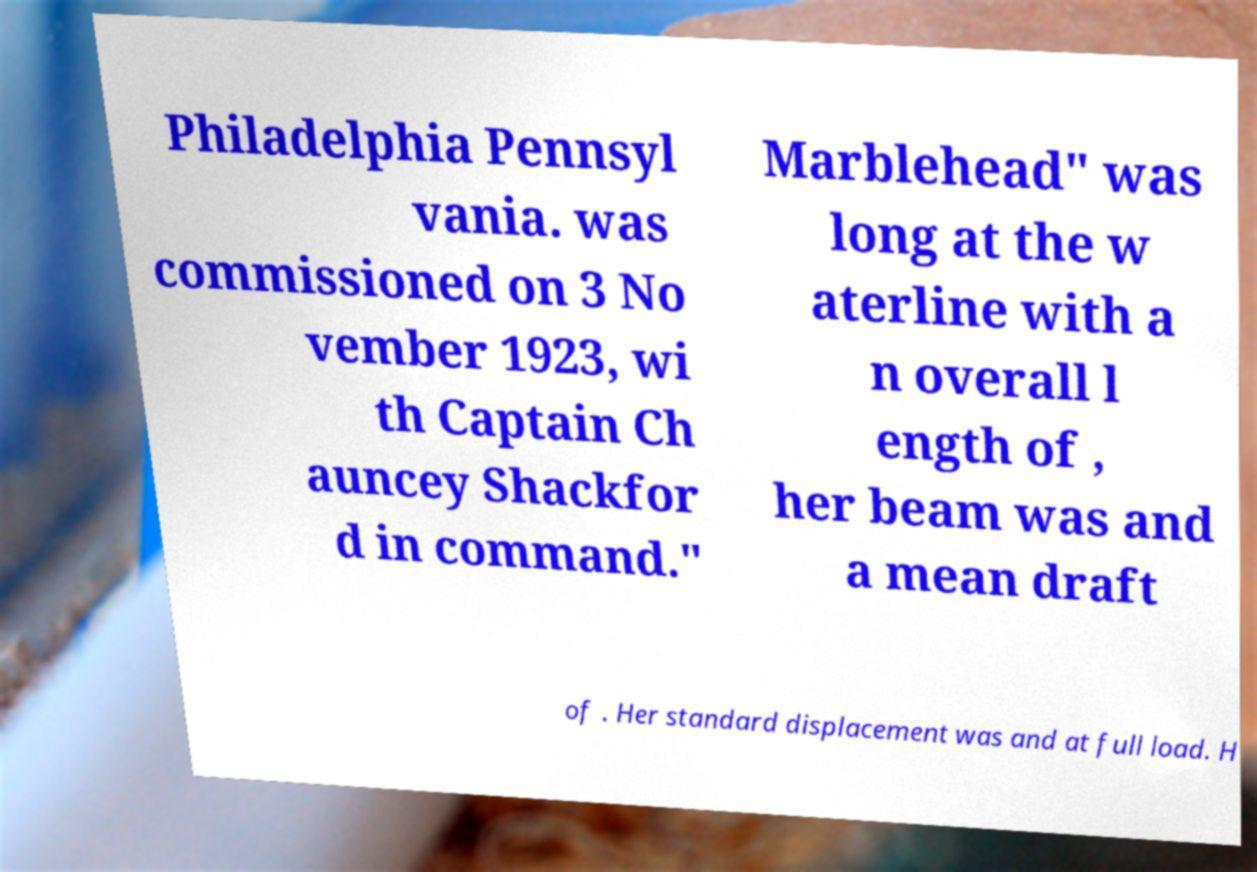What messages or text are displayed in this image? I need them in a readable, typed format. Philadelphia Pennsyl vania. was commissioned on 3 No vember 1923, wi th Captain Ch auncey Shackfor d in command." Marblehead" was long at the w aterline with a n overall l ength of , her beam was and a mean draft of . Her standard displacement was and at full load. H 